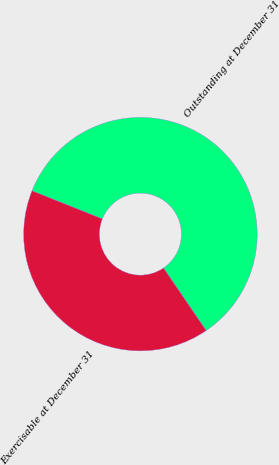<chart> <loc_0><loc_0><loc_500><loc_500><pie_chart><fcel>Outstanding at December 31<fcel>Exercisable at December 31<nl><fcel>59.43%<fcel>40.57%<nl></chart> 